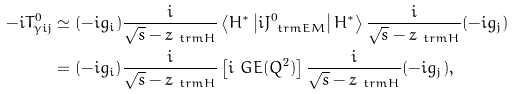Convert formula to latex. <formula><loc_0><loc_0><loc_500><loc_500>- i T _ { \gamma i j } ^ { 0 } & \simeq ( - i g _ { i } ) \frac { i } { \sqrt { s } - z _ { \ t r m { H } } } \left \langle H ^ { \ast } \left | i J _ { \ t r m { E M } } ^ { 0 } \right | H ^ { \ast } \right \rangle \frac { i } { \sqrt { s } - z _ { \ t r m { H } } } ( - i g _ { j } ) \\ & = ( - i g _ { i } ) \frac { i } { \sqrt { s } - z _ { \ t r m { H } } } \left [ i \ G E ( Q ^ { 2 } ) \right ] \frac { i } { \sqrt { s } - z _ { \ t r m { H } } } ( - i g _ { j } ) ,</formula> 